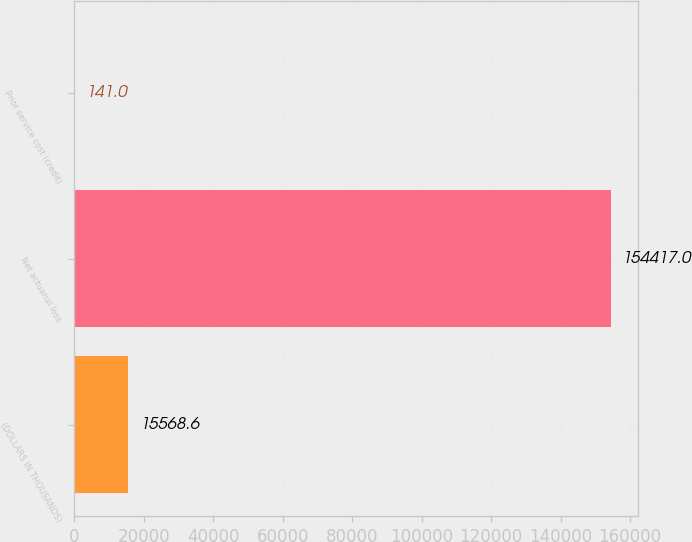Convert chart to OTSL. <chart><loc_0><loc_0><loc_500><loc_500><bar_chart><fcel>(DOLLARS IN THOUSANDS)<fcel>Net actuarial loss<fcel>Prior service cost (credit)<nl><fcel>15568.6<fcel>154417<fcel>141<nl></chart> 